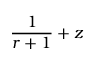<formula> <loc_0><loc_0><loc_500><loc_500>{ \frac { 1 } { r + 1 } } + z</formula> 